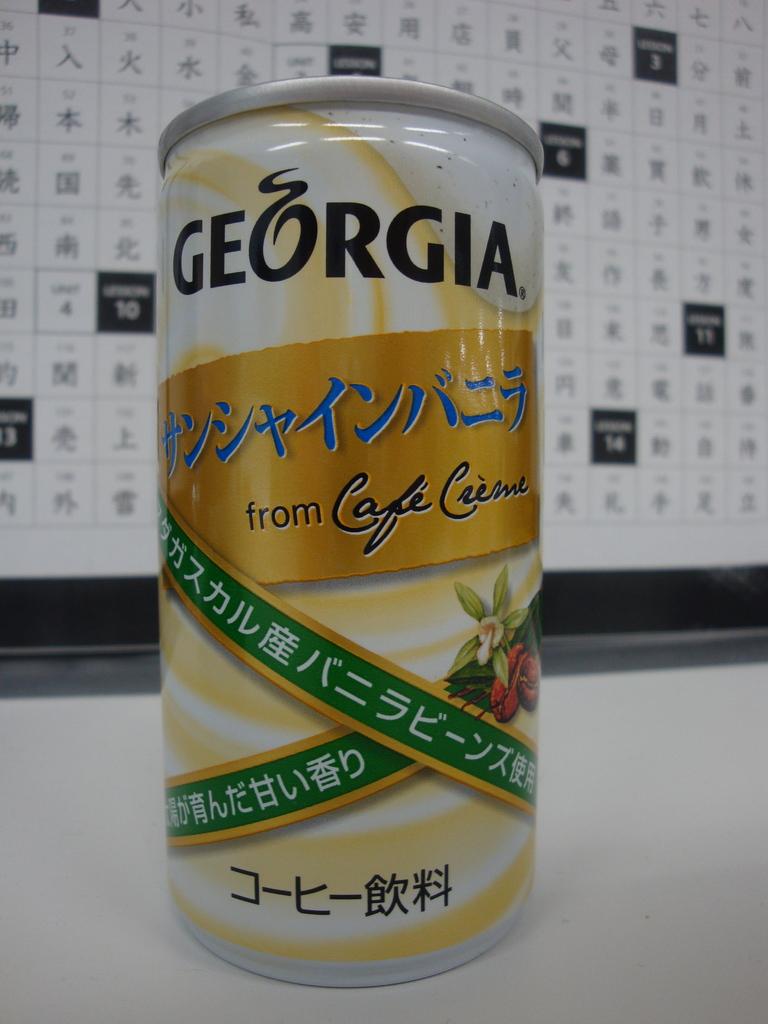What is the name of this drink, printed at the top of this can?
Your response must be concise. Georgia. What cafe is the drink from?
Provide a succinct answer. Creme. 